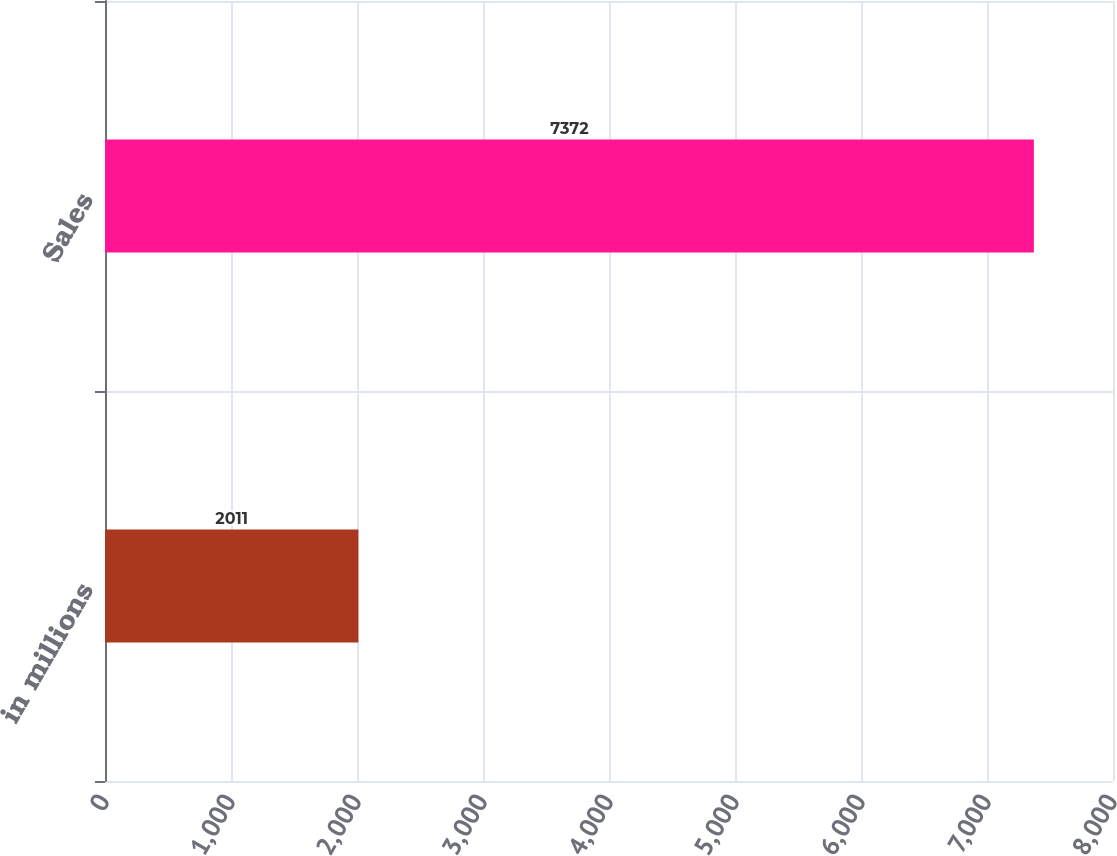<chart> <loc_0><loc_0><loc_500><loc_500><bar_chart><fcel>in millions<fcel>Sales<nl><fcel>2011<fcel>7372<nl></chart> 